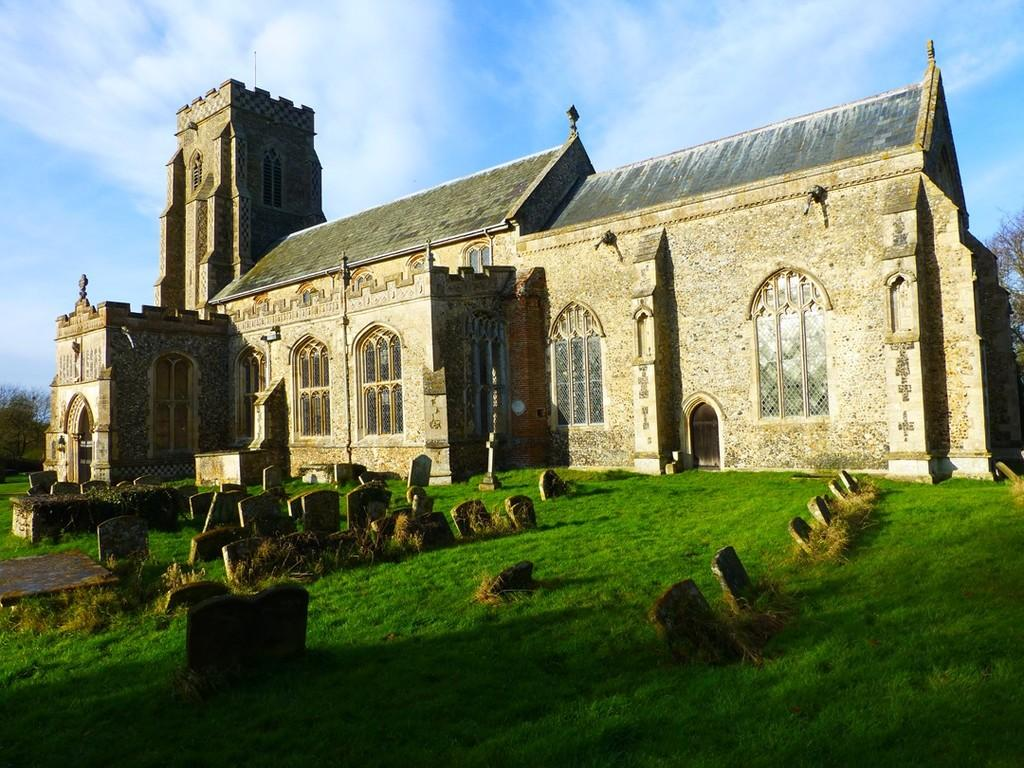What type of ground covering can be seen in the image? The ground in the image is covered with grass. What is the main subject of the image? The main subject of the image is a graveyard. What can be seen in the background of the image? There is a building visible in the background, and trees are also present. How would you describe the weather in the image? The sky is cloudy in the image. What type of holiday is being celebrated in the image? There is no indication of a holiday being celebrated in the image. What type of drug is being used by the trees in the image? There are no drugs present in the image, and trees do not use drugs. 